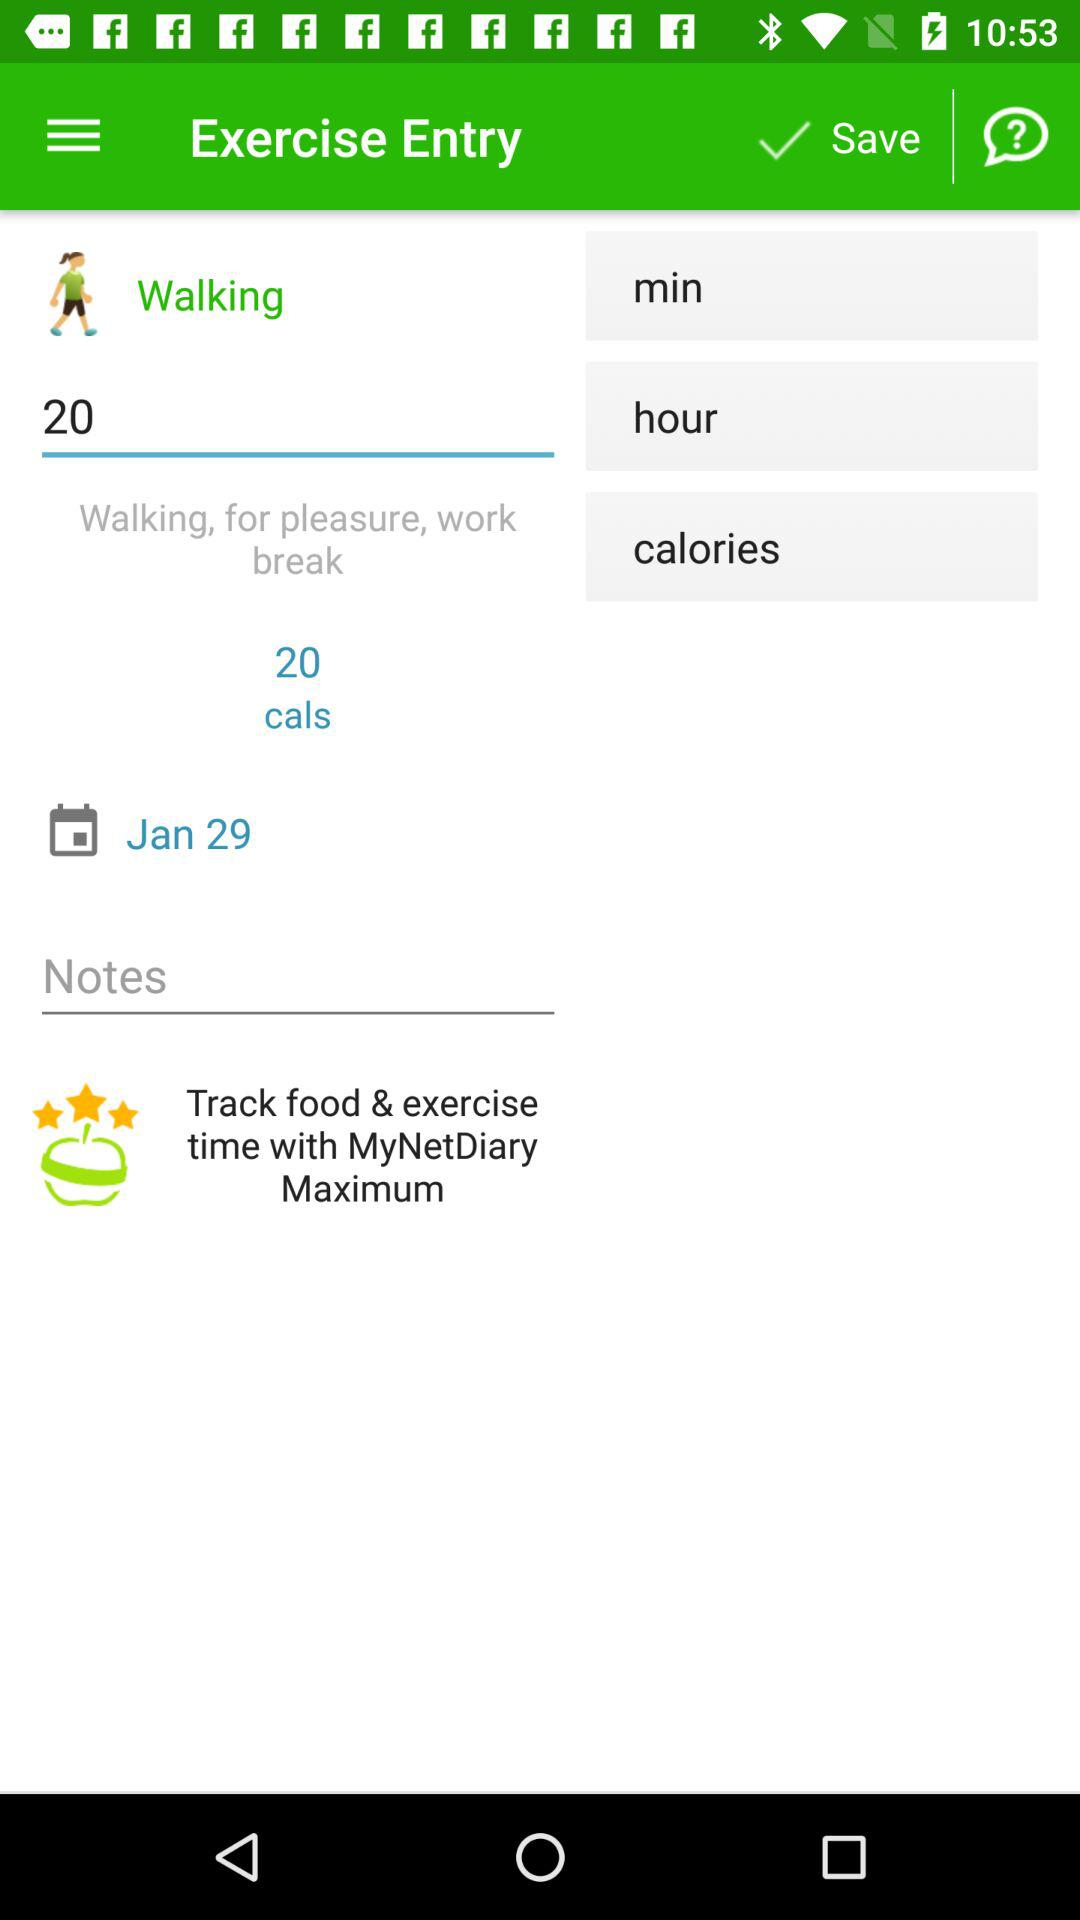What is the date of the exercise? The date of the exercise is January 29. 